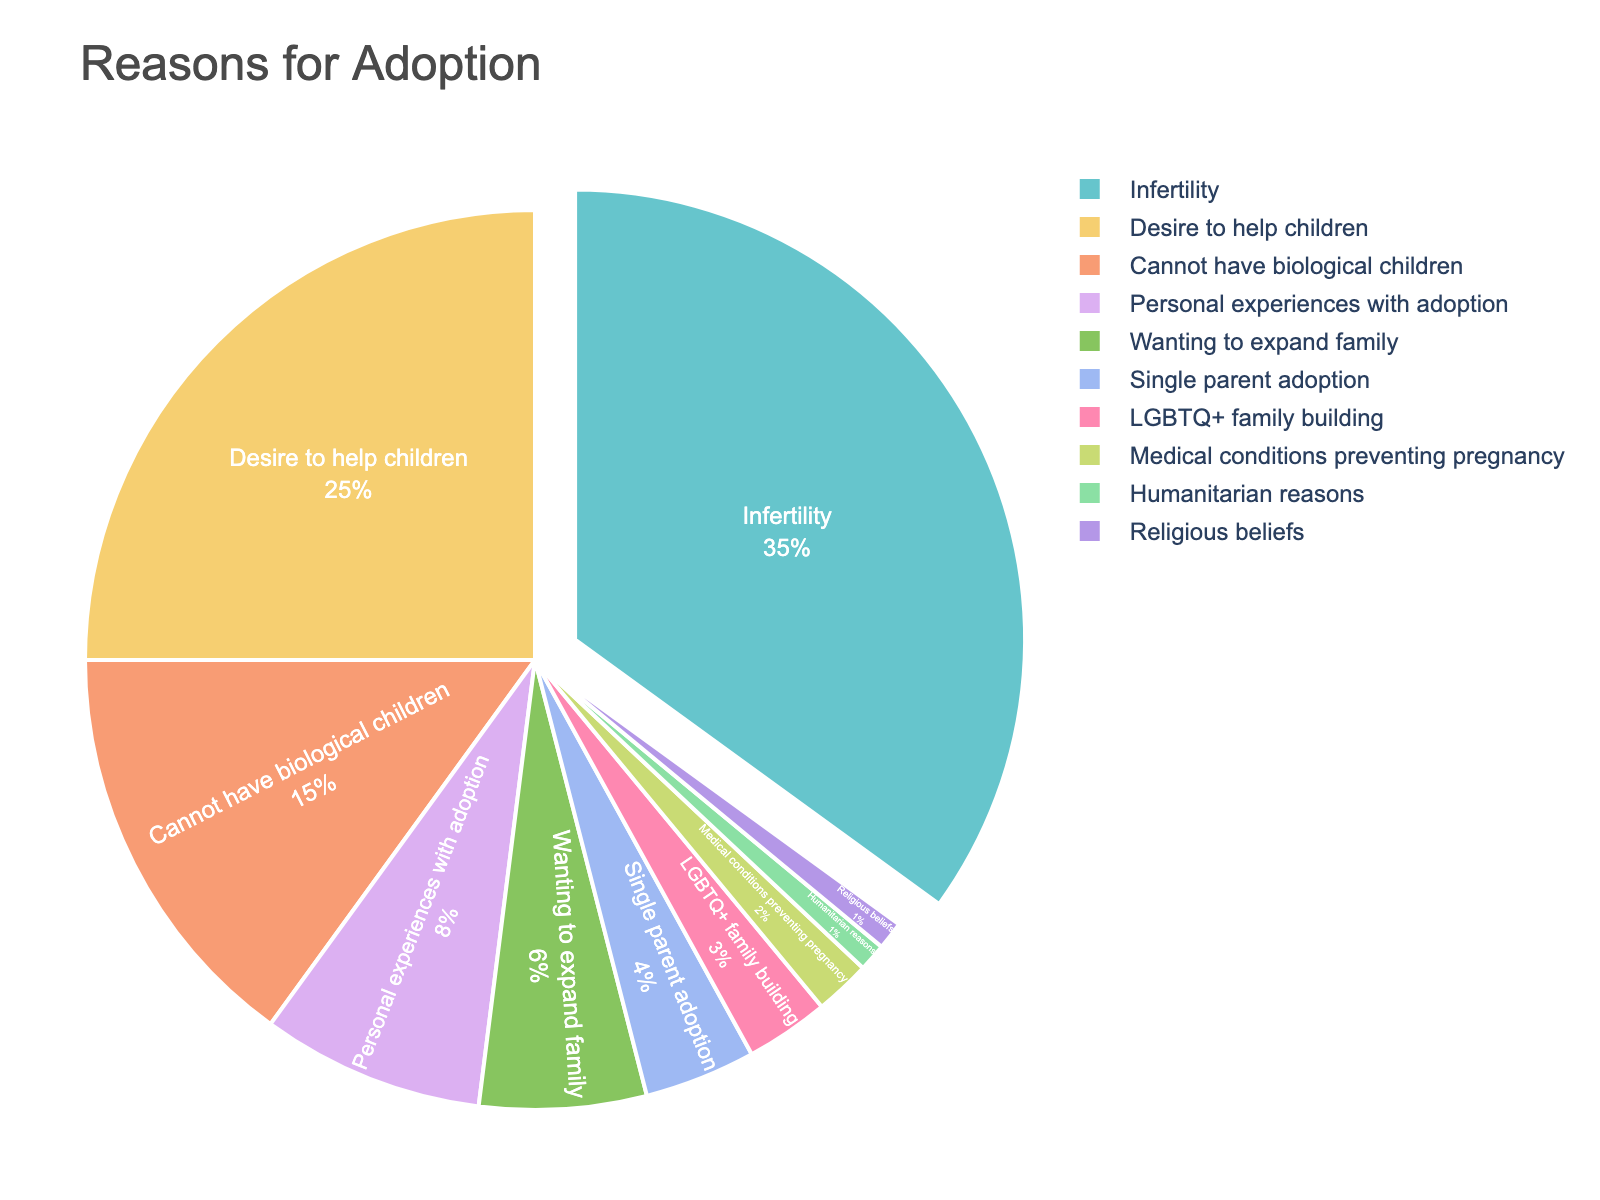What is the most common reason for adoption according to the pie chart? The largest section of the pie chart represents the most common reason. Infertility has the highest percentage (35%), making it the most common reason.
Answer: Infertility Which two reasons combined account for 40% of the total reasons? Adding the percentages of two sections until their sum is 40%. "Cannot have biological children" and "Desire to help children" together equal 15% + 25% = 40%.
Answer: Cannot have biological children and Desire to help children How much more common is "Infertility" compared to "Cannot have biological children"? Subtract the percentage of "Cannot have biological children" (15%) from "Infertility" (35%). The difference is 35% - 15% = 20%.
Answer: 20% What percentage of adoptive parents cite reasons related to their inability to conceive or carry a pregnancy (Infertility + Cannot have biological children + Medical conditions preventing pregnancy)? Sum the percentages for "Infertility" (35%), "Cannot have biological children" (15%), and "Medical conditions preventing pregnancy" (2%). The total is 35% + 15% + 2% = 52%.
Answer: 52% Which category in the pie chart is visually indicated as the most significant reason for adoption? The section pulled away from the main pie, highlighting it as the most significant. Infertility is visually pulled away from the rest.
Answer: Infertility Arrange the reasons given in the pie chart from most to least common. Order the reasons based on their respective percentages from highest to lowest. The order is: Infertility (35%), Desire to help children (25%), Cannot have biological children (15%), Personal experiences with adoption (8%), Wanting to expand family (6%), Single parent adoption (4%), LGBTQ+ family building (3%), Medical conditions preventing pregnancy (2%), Humanitarian reasons (1%), Religious beliefs (1%).
Answer: Infertility, Desire to help children, Cannot have biological children, Personal experiences with adoption, Wanting to expand family, Single parent adoption, LGBTQ+ family building, Medical conditions preventing pregnancy, Humanitarian reasons, Religious beliefs If you combine "Desire to help children" and "Humanitarian reasons," what percentage of adoptive parents do these reasons represent? Sum the percentages of "Desire to help children" (25%) and "Humanitarian reasons" (1%). The total is 25% + 1% = 26%.
Answer: 26% What percentage of adoptive parents are motivated by their personal experiences with adoption? Identify the relevant section "Personal experiences with adoption" and find its percentage, which is 8%.
Answer: 8% Are "Religious beliefs" and "Humanitarian reasons" equally common as reasons for adoption? Check the percentages for "Religious beliefs" and "Humanitarian reasons." Both have a percentage of 1%.
Answer: Yes Which is more common: "Single parent adoption" or "LGBTQ+ family building"? Compare the percentages of the sections "Single parent adoption" (4%) and "LGBTQ+ family building" (3%). Single parent adoption is more common.
Answer: Single parent adoption 